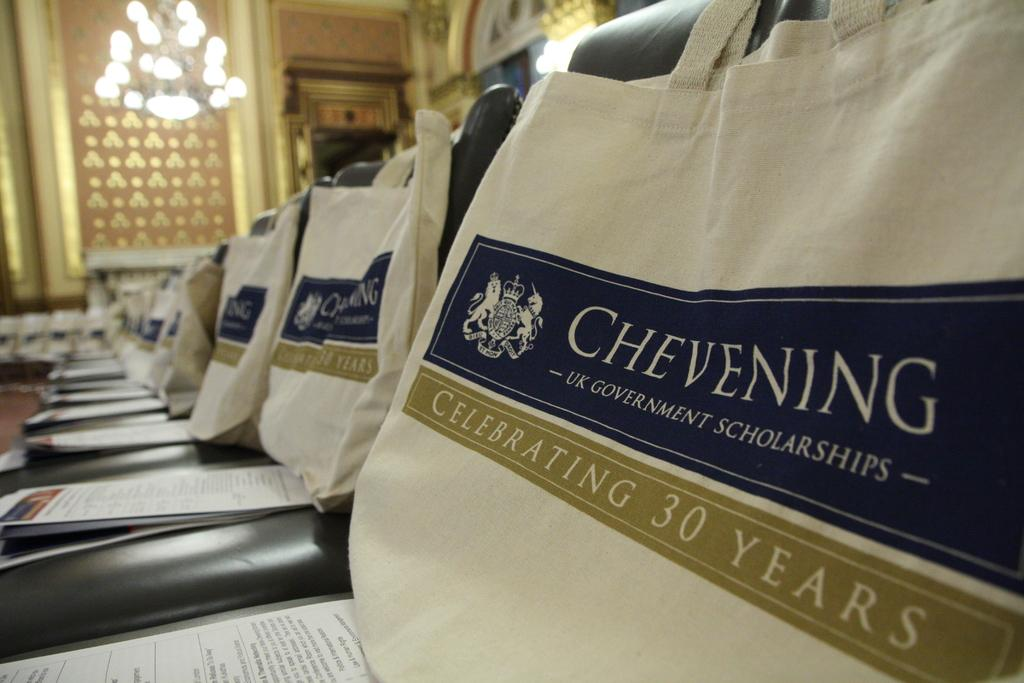<image>
Describe the image concisely. A bag indicates that Chevening is celebrating 30 years. 